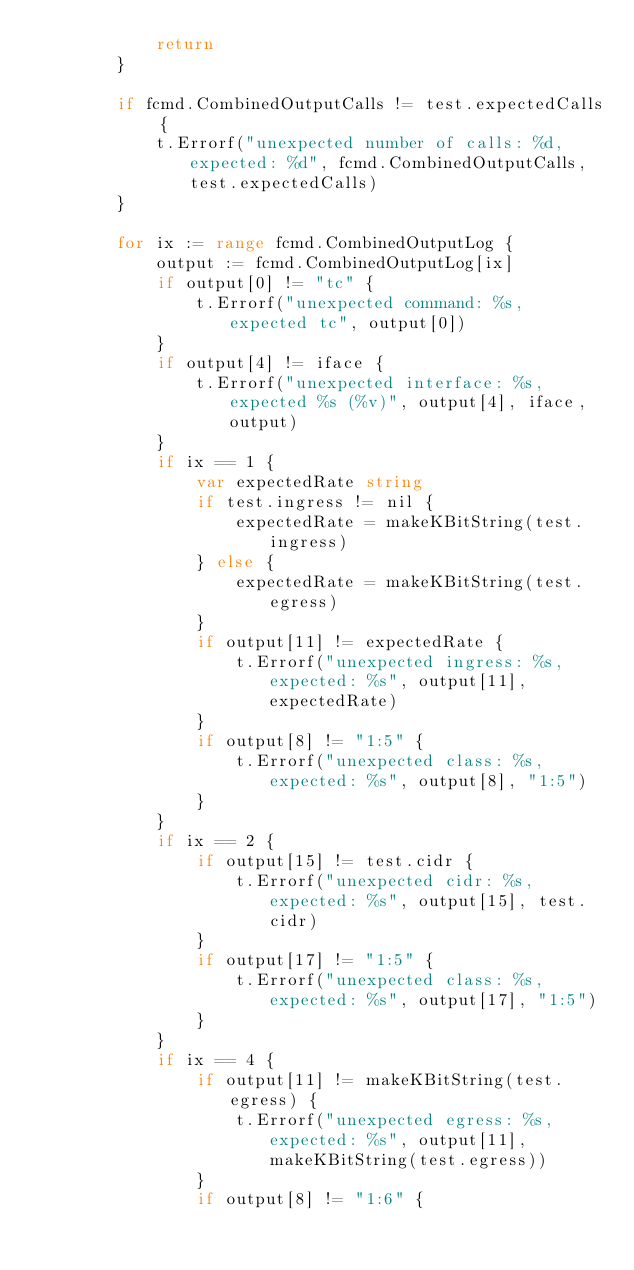<code> <loc_0><loc_0><loc_500><loc_500><_Go_>			return
		}

		if fcmd.CombinedOutputCalls != test.expectedCalls {
			t.Errorf("unexpected number of calls: %d, expected: %d", fcmd.CombinedOutputCalls, test.expectedCalls)
		}

		for ix := range fcmd.CombinedOutputLog {
			output := fcmd.CombinedOutputLog[ix]
			if output[0] != "tc" {
				t.Errorf("unexpected command: %s, expected tc", output[0])
			}
			if output[4] != iface {
				t.Errorf("unexpected interface: %s, expected %s (%v)", output[4], iface, output)
			}
			if ix == 1 {
				var expectedRate string
				if test.ingress != nil {
					expectedRate = makeKBitString(test.ingress)
				} else {
					expectedRate = makeKBitString(test.egress)
				}
				if output[11] != expectedRate {
					t.Errorf("unexpected ingress: %s, expected: %s", output[11], expectedRate)
				}
				if output[8] != "1:5" {
					t.Errorf("unexpected class: %s, expected: %s", output[8], "1:5")
				}
			}
			if ix == 2 {
				if output[15] != test.cidr {
					t.Errorf("unexpected cidr: %s, expected: %s", output[15], test.cidr)
				}
				if output[17] != "1:5" {
					t.Errorf("unexpected class: %s, expected: %s", output[17], "1:5")
				}
			}
			if ix == 4 {
				if output[11] != makeKBitString(test.egress) {
					t.Errorf("unexpected egress: %s, expected: %s", output[11], makeKBitString(test.egress))
				}
				if output[8] != "1:6" {</code> 